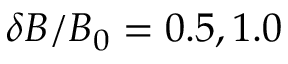Convert formula to latex. <formula><loc_0><loc_0><loc_500><loc_500>\delta B / B _ { 0 } = 0 . 5 , 1 . 0</formula> 